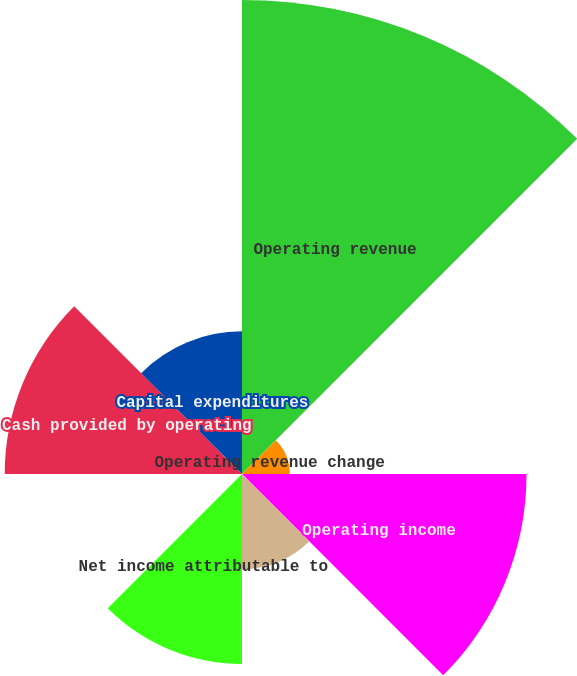<chart> <loc_0><loc_0><loc_500><loc_500><pie_chart><fcel>Operating revenue<fcel>Operating revenue change<fcel>Operating income<fcel>Operating margin<fcel>Net income attributable to<fcel>Diluted earnings per share<fcel>Cash provided by operating<fcel>Capital expenditures<nl><fcel>32.2%<fcel>3.25%<fcel>19.33%<fcel>6.47%<fcel>12.9%<fcel>0.04%<fcel>16.12%<fcel>9.69%<nl></chart> 